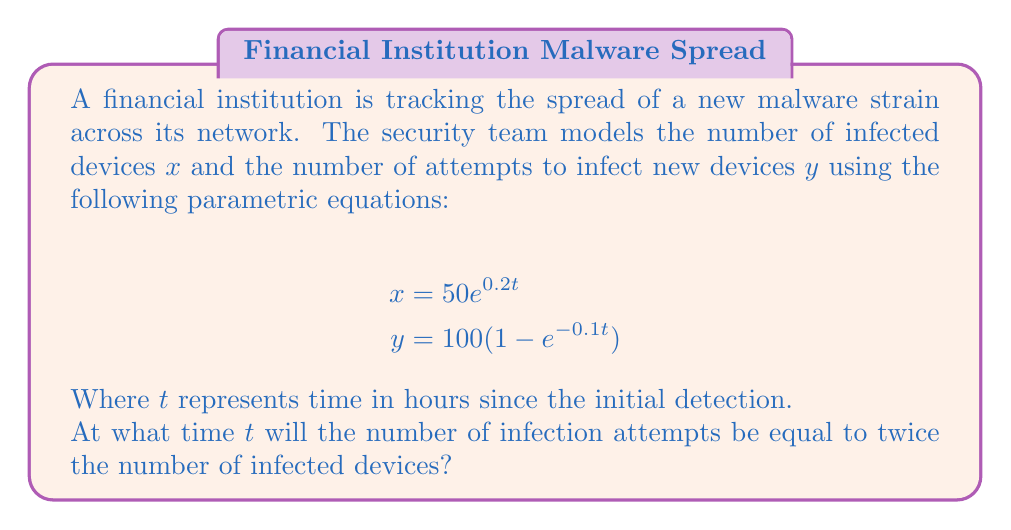Provide a solution to this math problem. To solve this problem, we need to follow these steps:

1) We're looking for the time $t$ when $y = 2x$. Let's set up this equation:

   $$100(1 - e^{-0.1t}) = 2(50e^{0.2t})$$

2) Simplify the right side:

   $$100(1 - e^{-0.1t}) = 100e^{0.2t}$$

3) Divide both sides by 100:

   $$1 - e^{-0.1t} = e^{0.2t}$$

4) Add $e^{-0.1t}$ to both sides:

   $$1 = e^{0.2t} + e^{-0.1t}$$

5) This equation can't be solved algebraically. We need to use numerical methods or graphing to find the solution.

6) Using a graphing calculator or computer software, we can plot $y = 1$ and $y = e^{0.2t} + e^{-0.1t}$ and find their intersection point.

7) The intersection occurs at approximately $t = 3.45$ hours.

This solution makes sense in the context of malware spread. Initially, the number of infected devices grows quickly while infection attempts are low. As time passes, more devices become infected, leading to an increase in infection attempts. The point where attempts are twice the number of infected devices represents a critical juncture in the malware's spread.
Answer: The number of infection attempts will be equal to twice the number of infected devices after approximately 3.45 hours. 